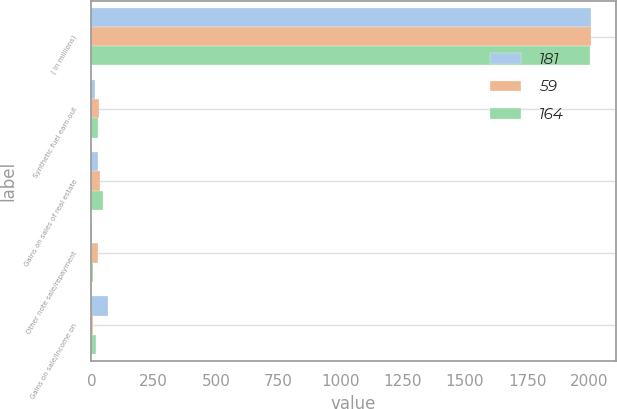<chart> <loc_0><loc_0><loc_500><loc_500><stacked_bar_chart><ecel><fcel>( in millions)<fcel>Synthetic fuel earn-out<fcel>Gains on sales of real estate<fcel>Other note sale/repayment<fcel>Gains on sale/income on<nl><fcel>181<fcel>2006<fcel>15<fcel>26<fcel>2<fcel>68<nl><fcel>59<fcel>2005<fcel>32<fcel>34<fcel>25<fcel>7<nl><fcel>164<fcel>2004<fcel>28<fcel>48<fcel>5<fcel>19<nl></chart> 